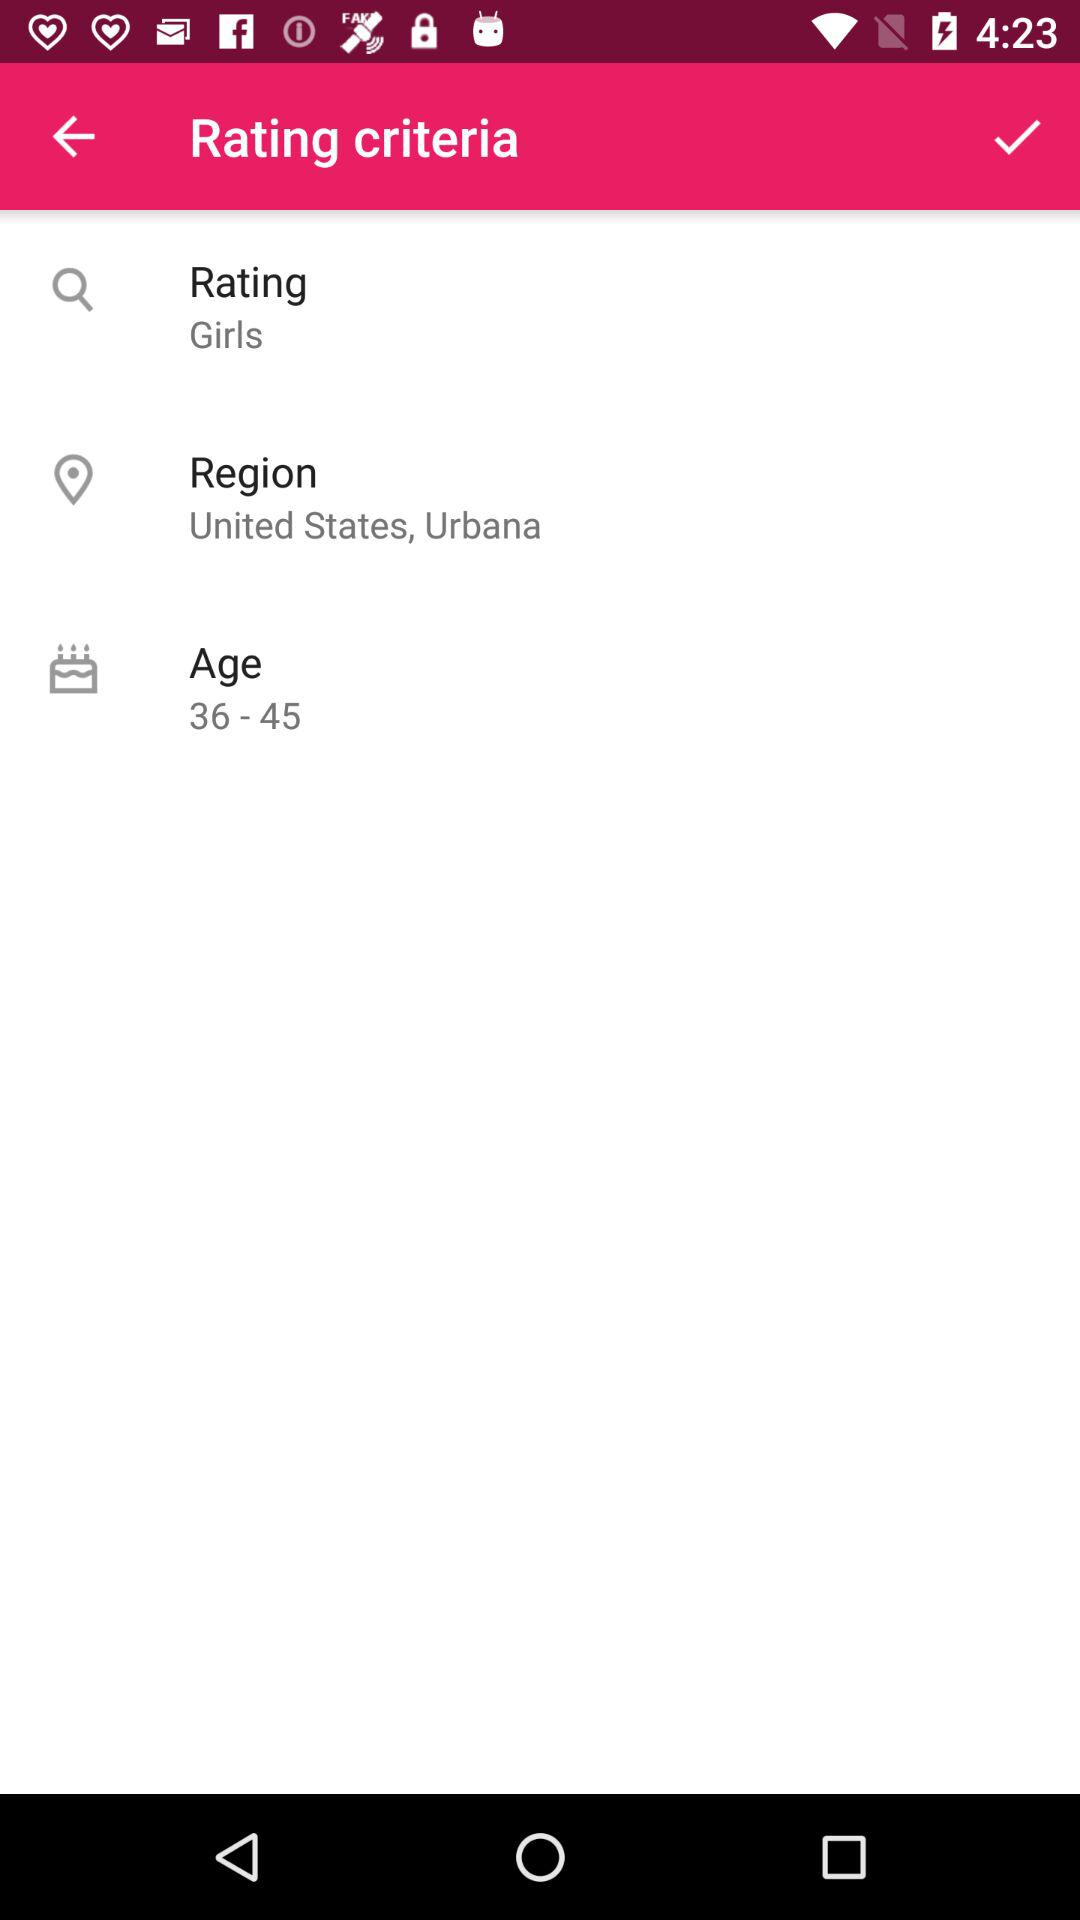What type of application or service could this rating criteria relate to? The rating criteria in the image appear to be for a social or dating application, intended to filter or categorize user preferences or profiles based on gender, specific location, and age group. 